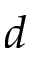Convert formula to latex. <formula><loc_0><loc_0><loc_500><loc_500>d</formula> 